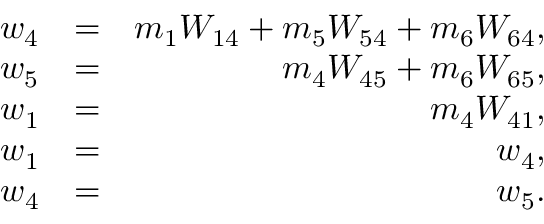Convert formula to latex. <formula><loc_0><loc_0><loc_500><loc_500>\begin{array} { r l r } { w _ { 4 } } & { = } & { m _ { 1 } W _ { 1 4 } + m _ { 5 } W _ { 5 4 } + m _ { 6 } W _ { 6 4 } , } \\ { w _ { 5 } } & { = } & { m _ { 4 } W _ { 4 5 } + m _ { 6 } W _ { 6 5 } , } \\ { w _ { 1 } } & { = } & { m _ { 4 } W _ { 4 1 } , } \\ { w _ { 1 } } & { = } & { w _ { 4 } , } \\ { w _ { 4 } } & { = } & { w _ { 5 } . } \end{array}</formula> 